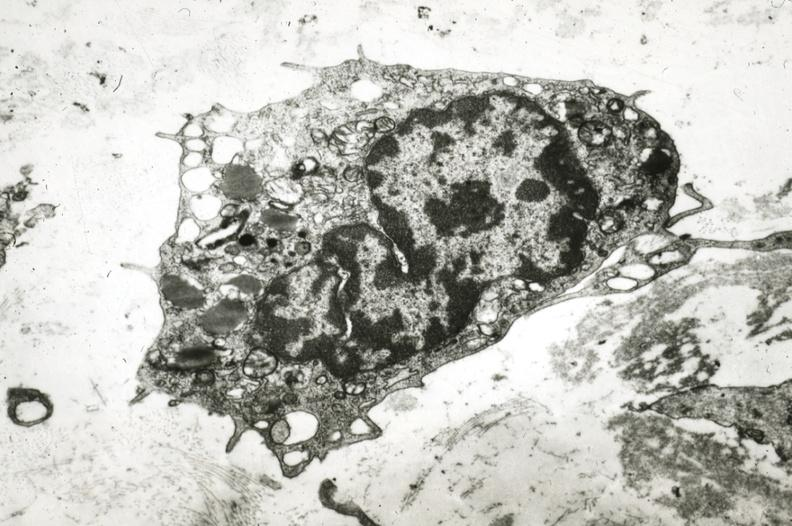s coronary artery present?
Answer the question using a single word or phrase. Yes 